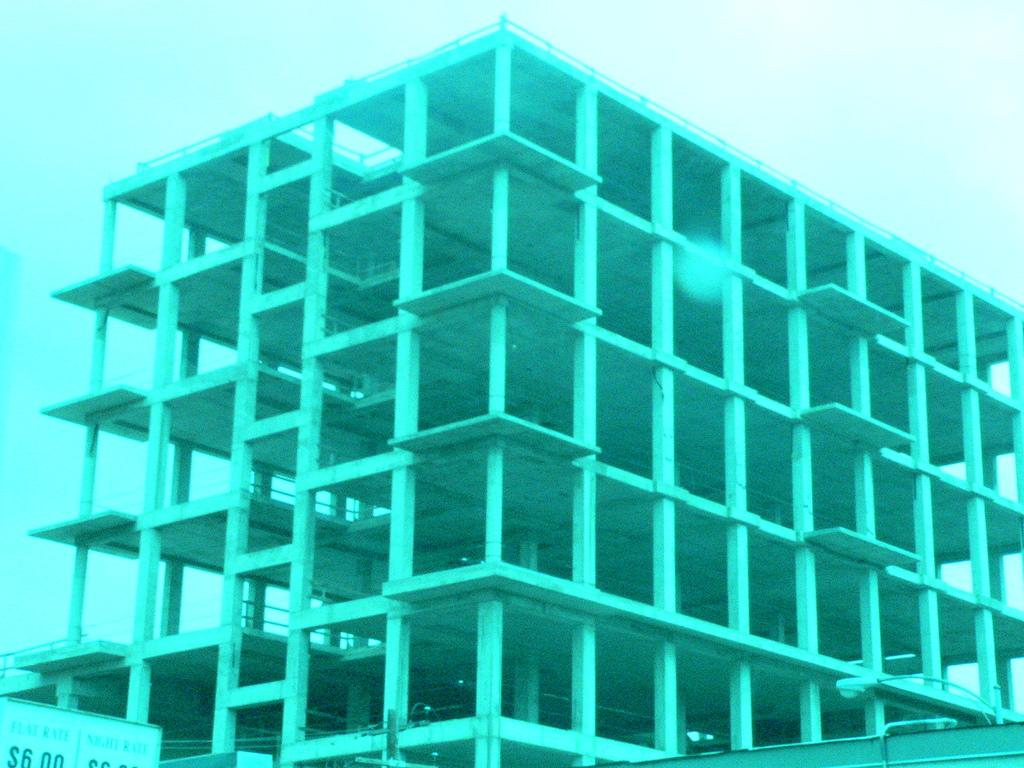What is the main subject in the center of the image? There is a building in the center of the image. What can be seen above the building in the image? The sky is visible at the top of the image. What color is the father's hair in the image? There is no father or hair present in the image; it only features a building and the sky. 